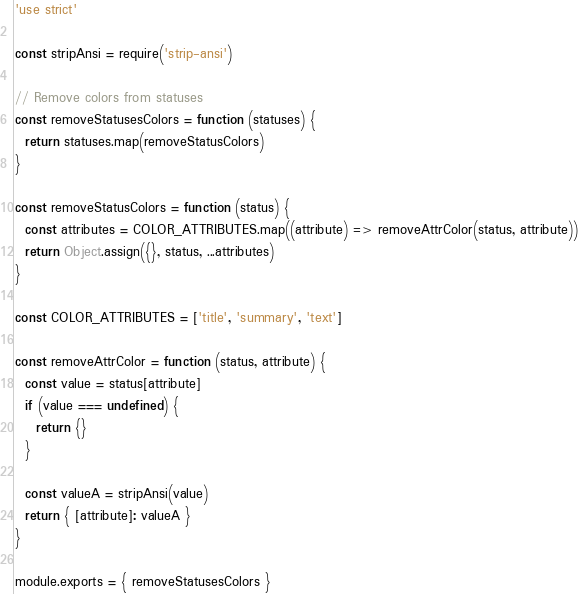Convert code to text. <code><loc_0><loc_0><loc_500><loc_500><_JavaScript_>'use strict'

const stripAnsi = require('strip-ansi')

// Remove colors from statuses
const removeStatusesColors = function (statuses) {
  return statuses.map(removeStatusColors)
}

const removeStatusColors = function (status) {
  const attributes = COLOR_ATTRIBUTES.map((attribute) => removeAttrColor(status, attribute))
  return Object.assign({}, status, ...attributes)
}

const COLOR_ATTRIBUTES = ['title', 'summary', 'text']

const removeAttrColor = function (status, attribute) {
  const value = status[attribute]
  if (value === undefined) {
    return {}
  }

  const valueA = stripAnsi(value)
  return { [attribute]: valueA }
}

module.exports = { removeStatusesColors }
</code> 